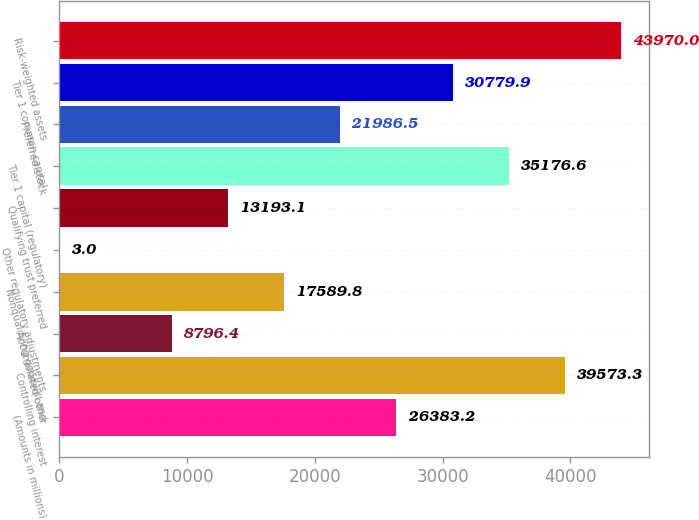Convert chart. <chart><loc_0><loc_0><loc_500><loc_500><bar_chart><fcel>(Amounts in millions)<fcel>Controlling interest<fcel>Accumulated other<fcel>Nonqualifying goodwill and<fcel>Other regulatory adjustments<fcel>Qualifying trust preferred<fcel>Tier 1 capital (regulatory)<fcel>Preferred stock<fcel>Tier 1 common capital<fcel>Risk-weighted assets<nl><fcel>26383.2<fcel>39573.3<fcel>8796.4<fcel>17589.8<fcel>3<fcel>13193.1<fcel>35176.6<fcel>21986.5<fcel>30779.9<fcel>43970<nl></chart> 